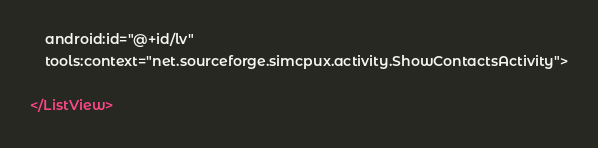Convert code to text. <code><loc_0><loc_0><loc_500><loc_500><_XML_>    android:id="@+id/lv"
    tools:context="net.sourceforge.simcpux.activity.ShowContactsActivity">

</ListView>
</code> 